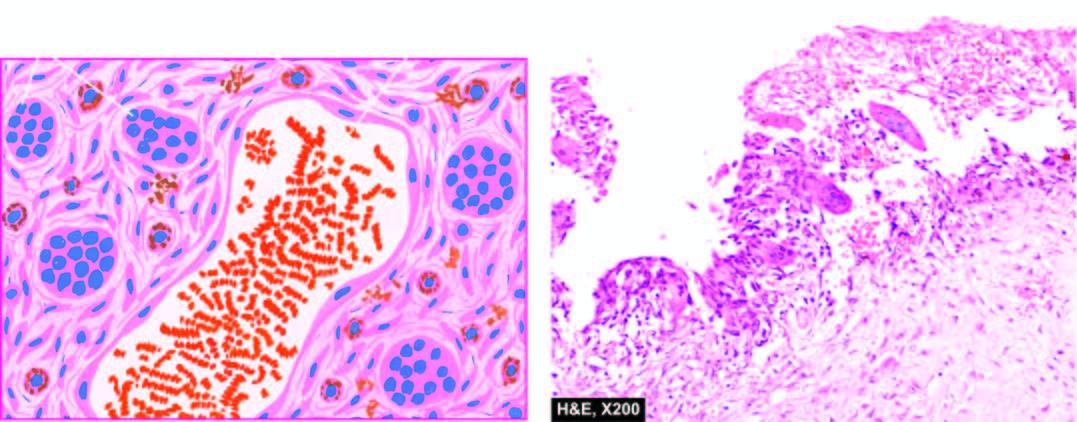s cut surface of the enlarged thyroid gland presence of aneurysmal spaces filled with blood, partly lined by endothelium and separated by connective tissue septa containing osteoclast-like giant cells along the wall of vascular spaces?
Answer the question using a single word or phrase. No 